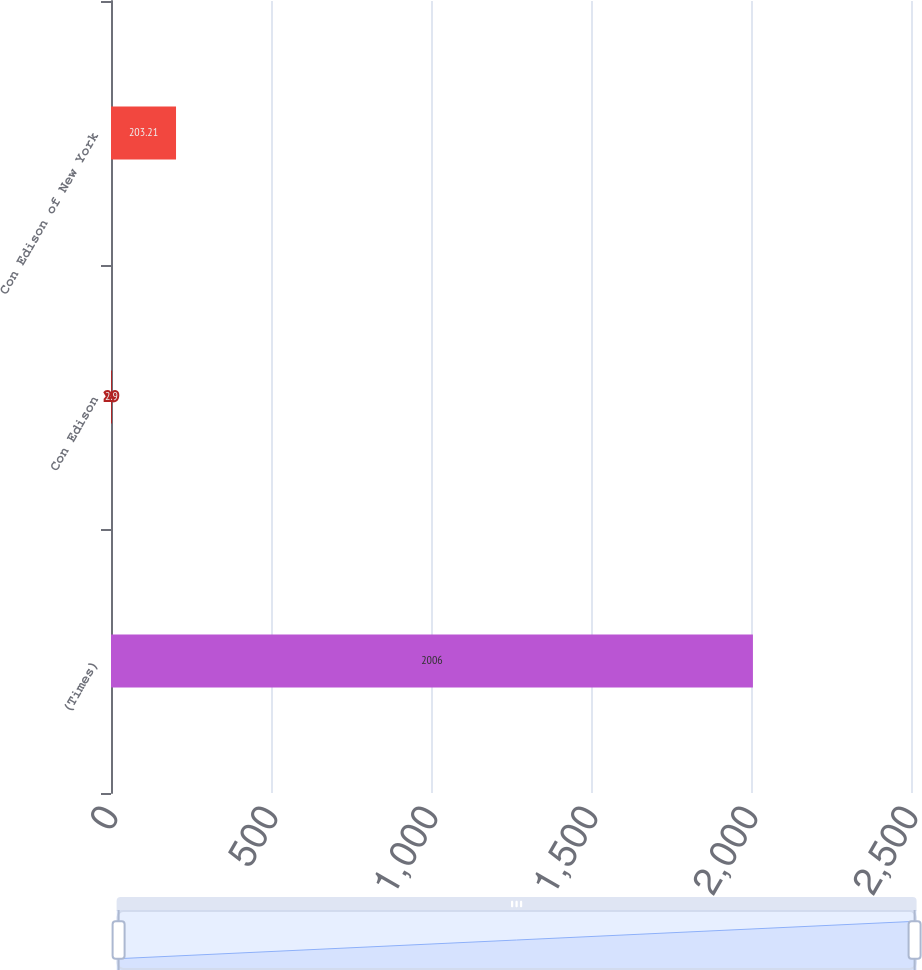<chart> <loc_0><loc_0><loc_500><loc_500><bar_chart><fcel>(Times)<fcel>Con Edison<fcel>Con Edison of New York<nl><fcel>2006<fcel>2.9<fcel>203.21<nl></chart> 